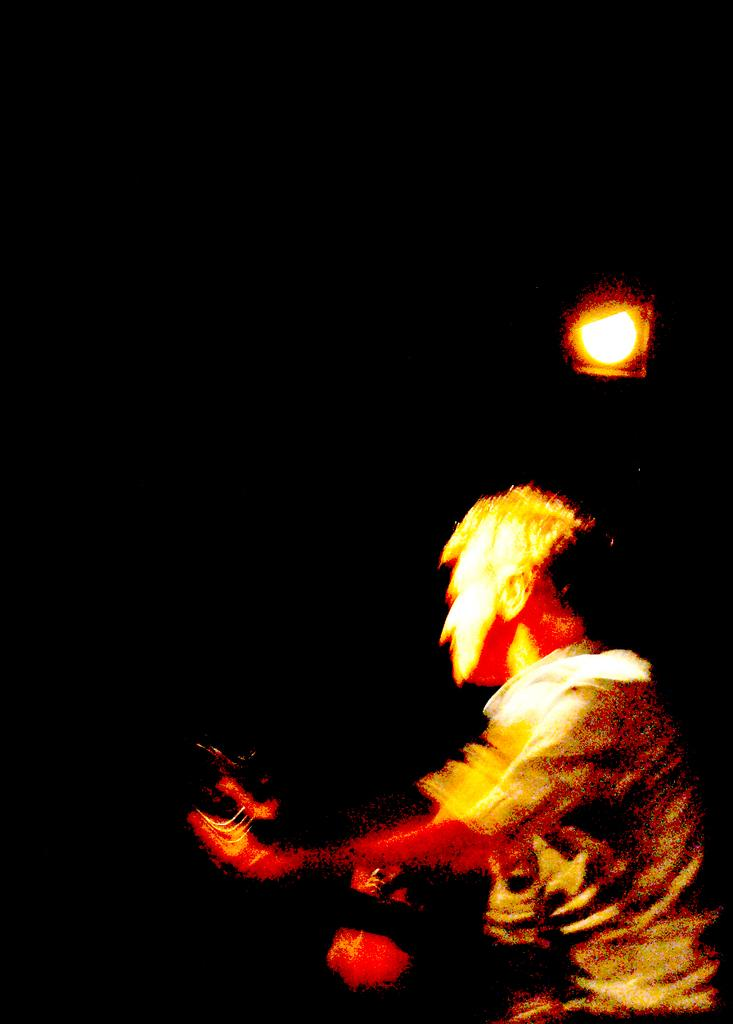Who is present in the image? There is a man in the image. What is the man wearing? The man is wearing a shirt. What can be seen at the top of the image? There is a light visible at the top of the image. What type of button does the man have on his shirt in the image? There is no button mentioned or visible on the man's shirt in the image. 